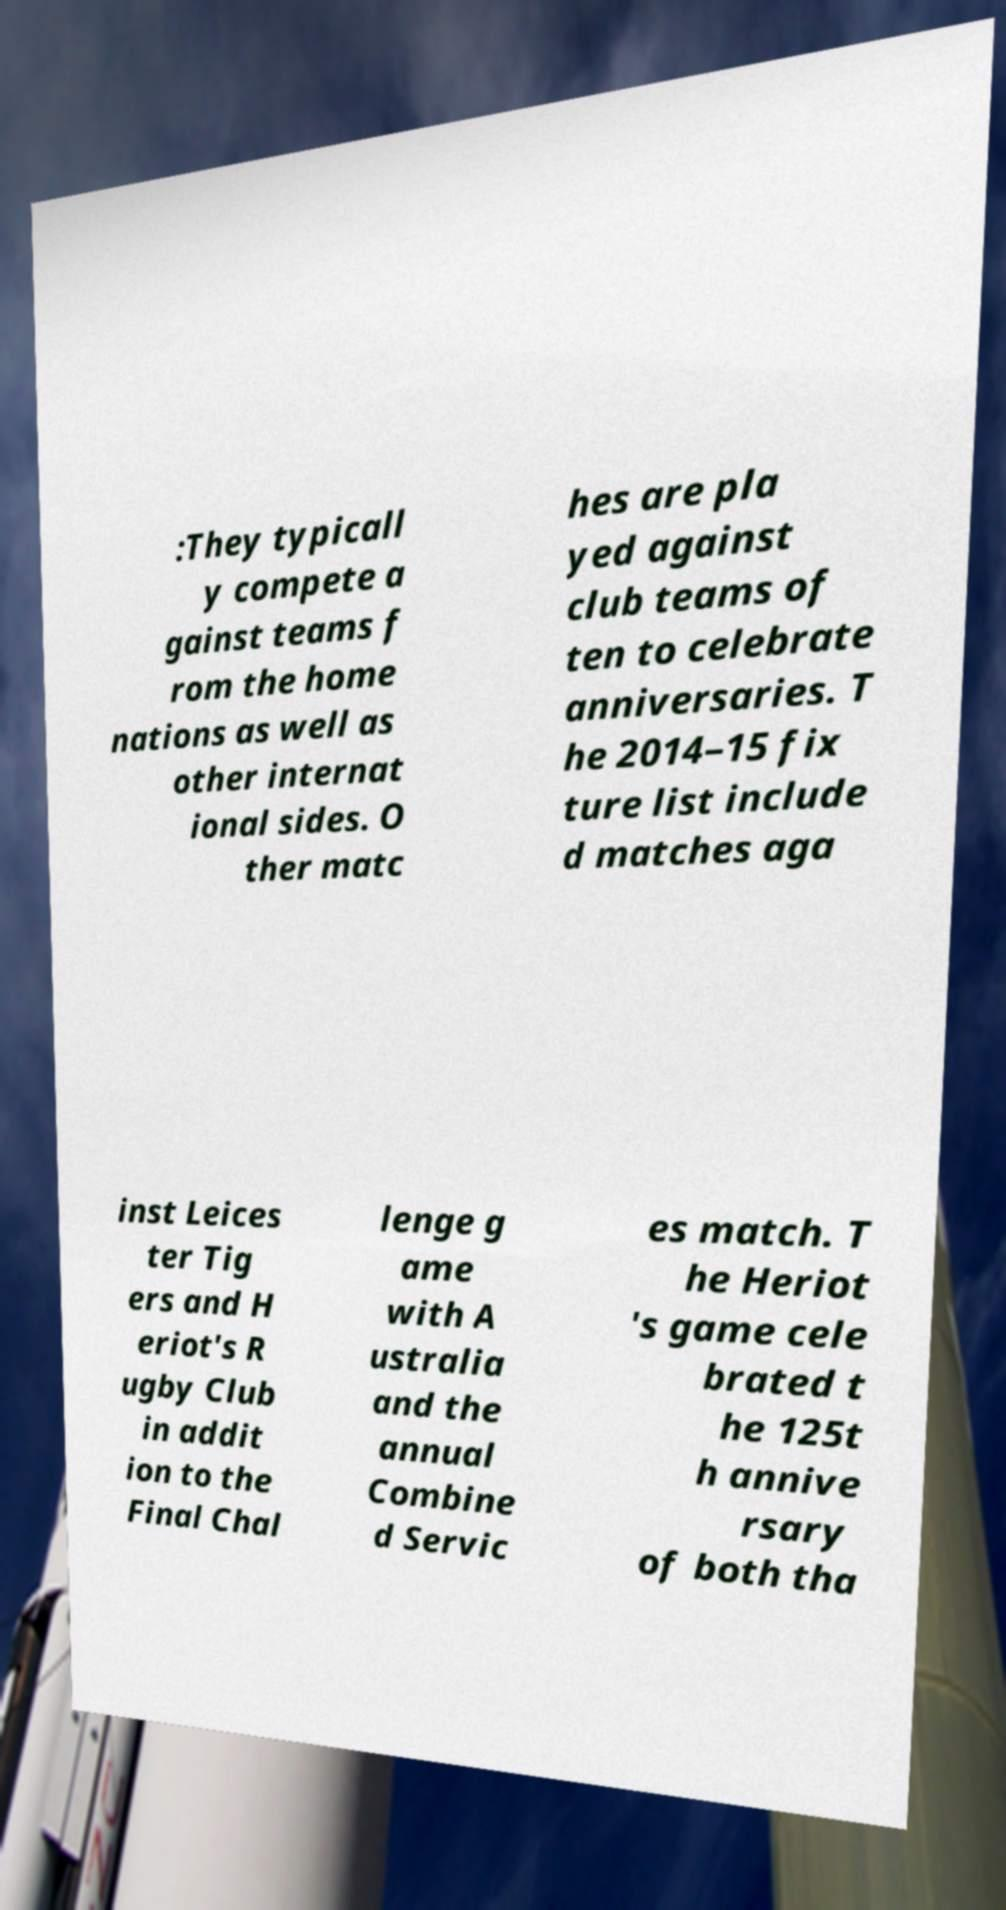Could you extract and type out the text from this image? :They typicall y compete a gainst teams f rom the home nations as well as other internat ional sides. O ther matc hes are pla yed against club teams of ten to celebrate anniversaries. T he 2014–15 fix ture list include d matches aga inst Leices ter Tig ers and H eriot's R ugby Club in addit ion to the Final Chal lenge g ame with A ustralia and the annual Combine d Servic es match. T he Heriot 's game cele brated t he 125t h annive rsary of both tha 